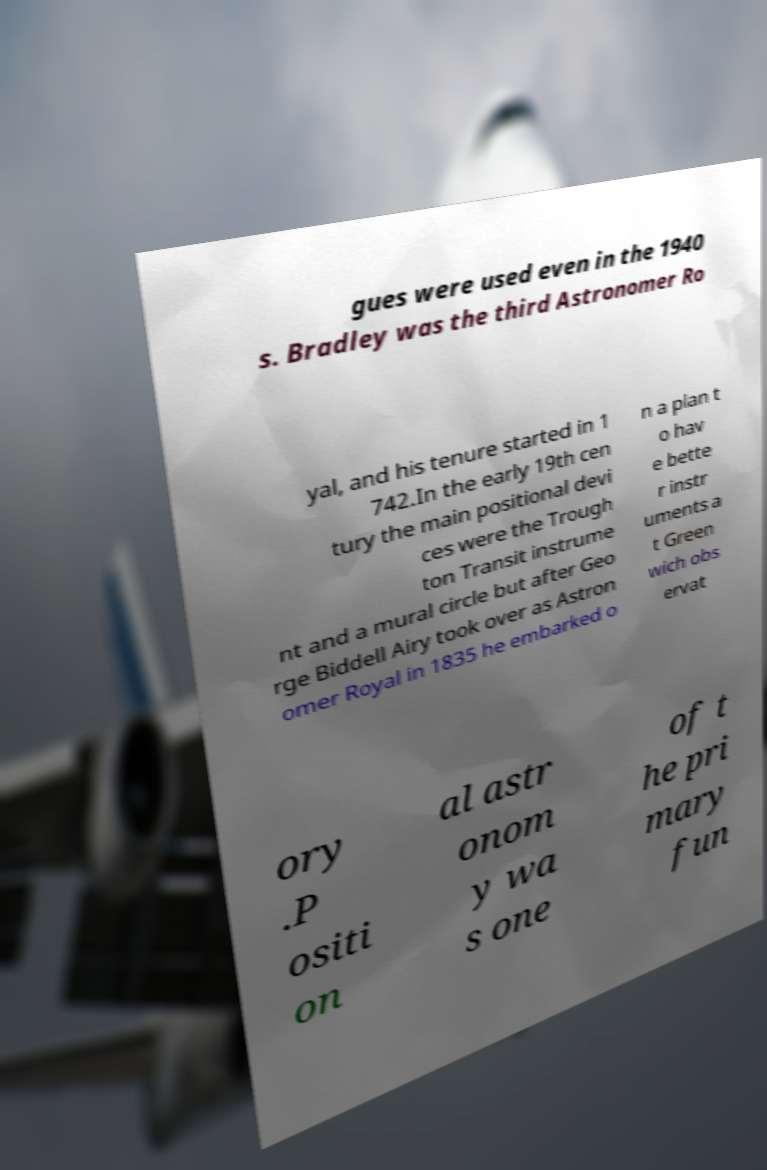Can you accurately transcribe the text from the provided image for me? gues were used even in the 1940 s. Bradley was the third Astronomer Ro yal, and his tenure started in 1 742.In the early 19th cen tury the main positional devi ces were the Trough ton Transit instrume nt and a mural circle but after Geo rge Biddell Airy took over as Astron omer Royal in 1835 he embarked o n a plan t o hav e bette r instr uments a t Green wich obs ervat ory .P ositi on al astr onom y wa s one of t he pri mary fun 